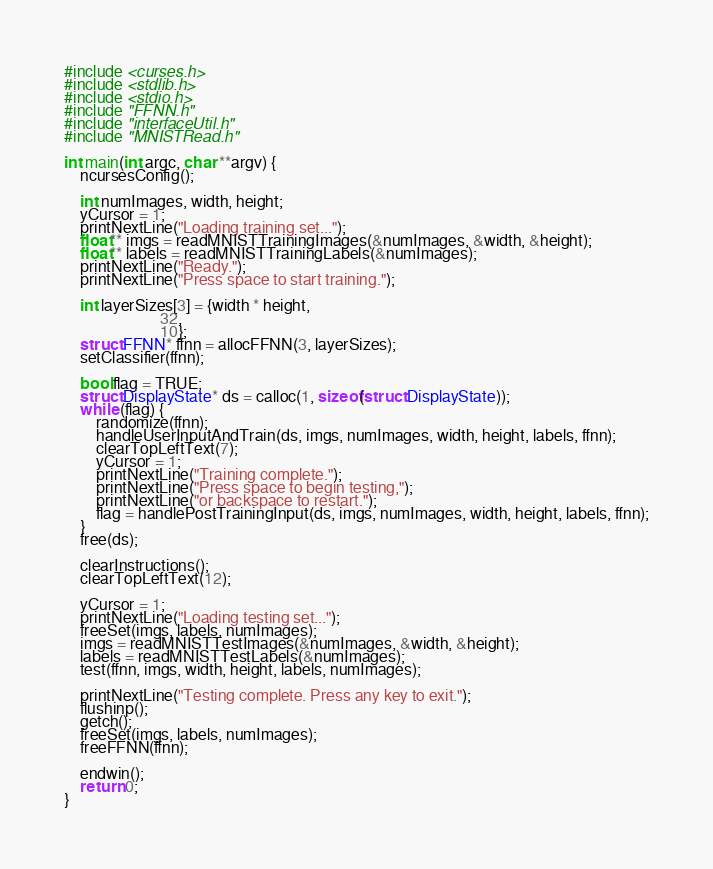Convert code to text. <code><loc_0><loc_0><loc_500><loc_500><_C_>#include <curses.h>
#include <stdlib.h>
#include <stdio.h>
#include "FFNN.h"
#include "interfaceUtil.h"
#include "MNISTRead.h"

int main(int argc, char **argv) {
	ncursesConfig();

	int numImages, width, height;
	yCursor = 1;
	printNextLine("Loading training set...");
	float** imgs = readMNISTTrainingImages(&numImages, &width, &height);
	float** labels = readMNISTTrainingLabels(&numImages);
	printNextLine("Ready.");
	printNextLine("Press space to start training.");

	int layerSizes[3] = {width * height, 
                        32,
                        10};
    struct FFNN* ffnn = allocFFNN(3, layerSizes);
    setClassifier(ffnn);

	bool flag = TRUE;
	struct DisplayState* ds = calloc(1, sizeof(struct DisplayState));
	while (flag) {
		randomize(ffnn);
		handleUserInputAndTrain(ds, imgs, numImages, width, height, labels, ffnn);
		clearTopLeftText(7);
		yCursor = 1;
		printNextLine("Training complete.");
		printNextLine("Press space to begin testing,");
		printNextLine("or backspace to restart.");
		flag = handlePostTrainingInput(ds, imgs, numImages, width, height, labels, ffnn);
	}
	free(ds);

	clearInstructions();
	clearTopLeftText(12);

	yCursor = 1;
	printNextLine("Loading testing set...");
	freeSet(imgs, labels, numImages);
	imgs = readMNISTTestImages(&numImages, &width, &height);
	labels = readMNISTTestLabels(&numImages);
	test(ffnn, imgs, width, height, labels, numImages);

	printNextLine("Testing complete. Press any key to exit.");
	flushinp();
	getch();
	freeSet(imgs, labels, numImages);
	freeFFNN(ffnn);

	endwin();
	return 0;
}
</code> 